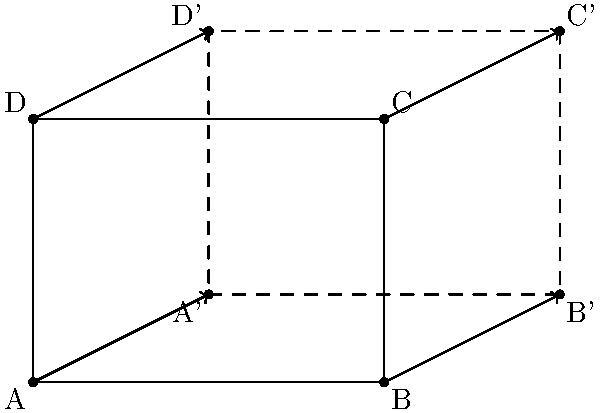In the diagram, rectangle ABCD is transformed to rectangle A'B'C'D'. This transformation can be described as a translation followed by a scaling. How might this geometric transformation relate to input validation in Python, particularly when dealing with user-provided coordinates? Provide a specific example of how you would implement this transformation and validate the input in Python. 1. Geometric Transformation:
   The transformation from ABCD to A'B'C'D' can be described as:
   a) Translation: Move 2 units right and 1 unit up
   b) Scaling: Scale by a factor of 1.5 (the new rectangle is 1.5 times larger)

2. Relation to Input Validation:
   When dealing with user-provided coordinates in Python, we need to ensure that the input is valid and within expected ranges. The transformation can be seen as a way to normalize or adjust user input.

3. Python Implementation:
   Let's create a function that performs this transformation and includes input validation:

   ```python
   def transform_and_validate(x, y):
       # Input validation
       if not isinstance(x, (int, float)) or not isinstance(y, (int, float)):
           raise ValueError("Coordinates must be numeric")
       
       if x < 0 or y < 0:
           raise ValueError("Coordinates must be non-negative")
       
       # Perform transformation
       x_transformed = (x + 2) * 1.5
       y_transformed = (y + 1) * 1.5
       
       # Output validation
       max_allowed = 1000  # Example maximum allowed value
       if x_transformed > max_allowed or y_transformed > max_allowed:
           raise ValueError("Transformed coordinates exceed allowed range")
       
       return x_transformed, y_transformed
   ```

4. Security Considerations:
   - Type checking prevents injection attacks
   - Range checking prevents buffer overflow issues
   - Output validation ensures the transformed values are within acceptable limits

5. Usage Example:
   ```python
   try:
       new_x, new_y = transform_and_validate(4, 3)
       print(f"Transformed coordinates: ({new_x}, {new_y})")
   except ValueError as e:
       print(f"Error: {e}")
   ```

This approach ensures that the input is properly validated, transformed, and the output is within expected ranges, mitigating potential security risks associated with user-provided coordinate data.
Answer: Implement input validation, perform coordinate transformation (translation and scaling), and validate output, using try-except blocks to handle potential errors securely. 